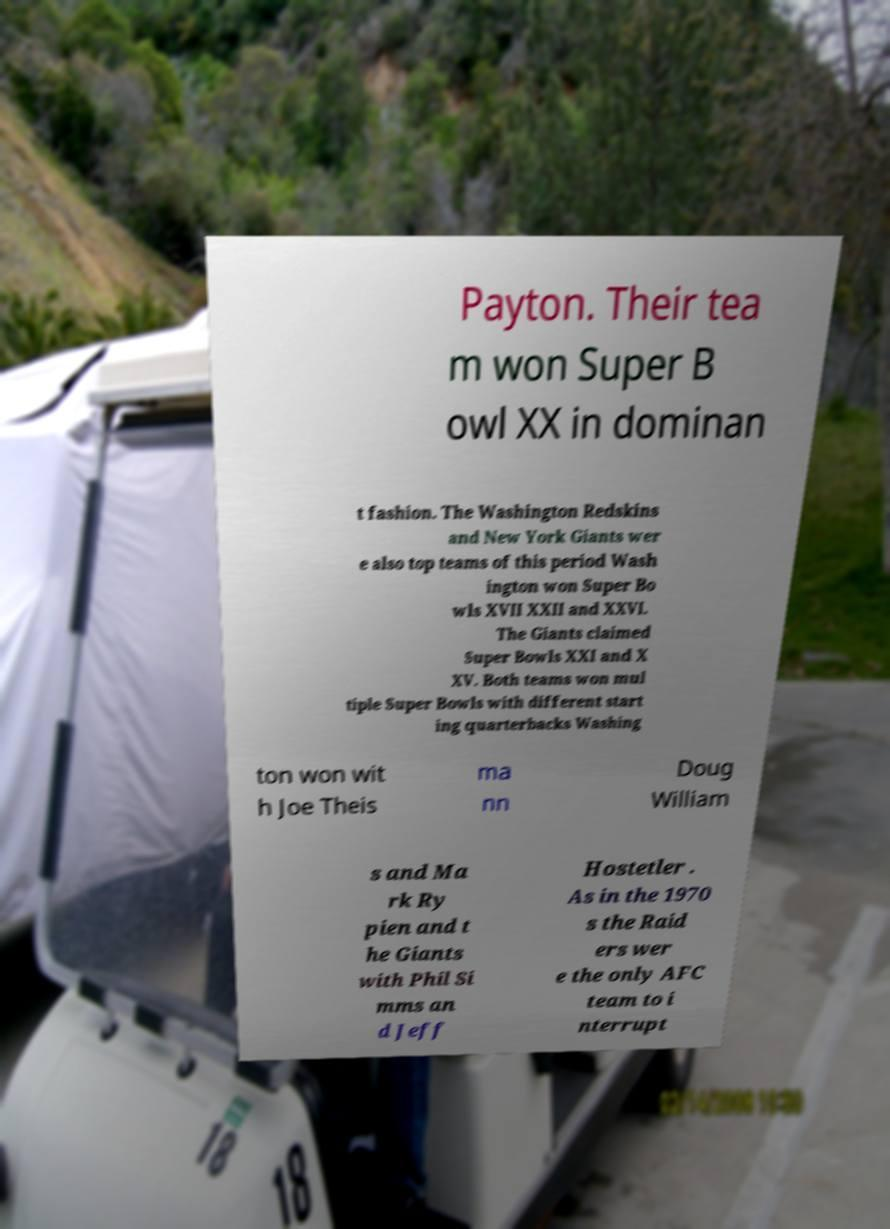What messages or text are displayed in this image? I need them in a readable, typed format. Payton. Their tea m won Super B owl XX in dominan t fashion. The Washington Redskins and New York Giants wer e also top teams of this period Wash ington won Super Bo wls XVII XXII and XXVI. The Giants claimed Super Bowls XXI and X XV. Both teams won mul tiple Super Bowls with different start ing quarterbacks Washing ton won wit h Joe Theis ma nn Doug William s and Ma rk Ry pien and t he Giants with Phil Si mms an d Jeff Hostetler . As in the 1970 s the Raid ers wer e the only AFC team to i nterrupt 